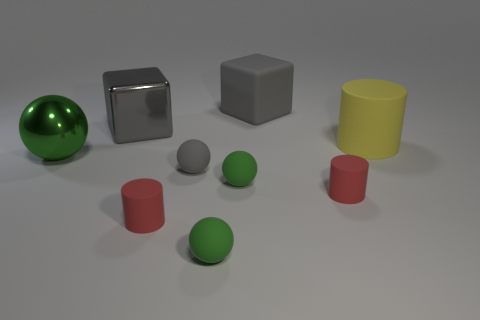Subtract all green cylinders. How many green spheres are left? 3 Subtract all red balls. Subtract all purple cubes. How many balls are left? 4 Add 1 red cylinders. How many objects exist? 10 Subtract all blocks. How many objects are left? 7 Add 1 cyan rubber cubes. How many cyan rubber cubes exist? 1 Subtract 0 gray cylinders. How many objects are left? 9 Subtract all large yellow matte things. Subtract all small gray objects. How many objects are left? 7 Add 2 large yellow rubber objects. How many large yellow rubber objects are left? 3 